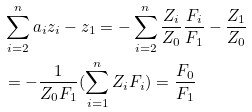Convert formula to latex. <formula><loc_0><loc_0><loc_500><loc_500>& \sum _ { i = 2 } ^ { n } a _ { i } z _ { i } - z _ { 1 } = - \sum _ { i = 2 } ^ { n } \frac { Z _ { i } } { Z _ { 0 } } \frac { F _ { i } } { F _ { 1 } } - \frac { Z _ { 1 } } { Z _ { 0 } } \\ & = - \frac { 1 } { Z _ { 0 } F _ { 1 } } ( \sum _ { i = 1 } ^ { n } Z _ { i } F _ { i } ) = \frac { F _ { 0 } } { F _ { 1 } }</formula> 